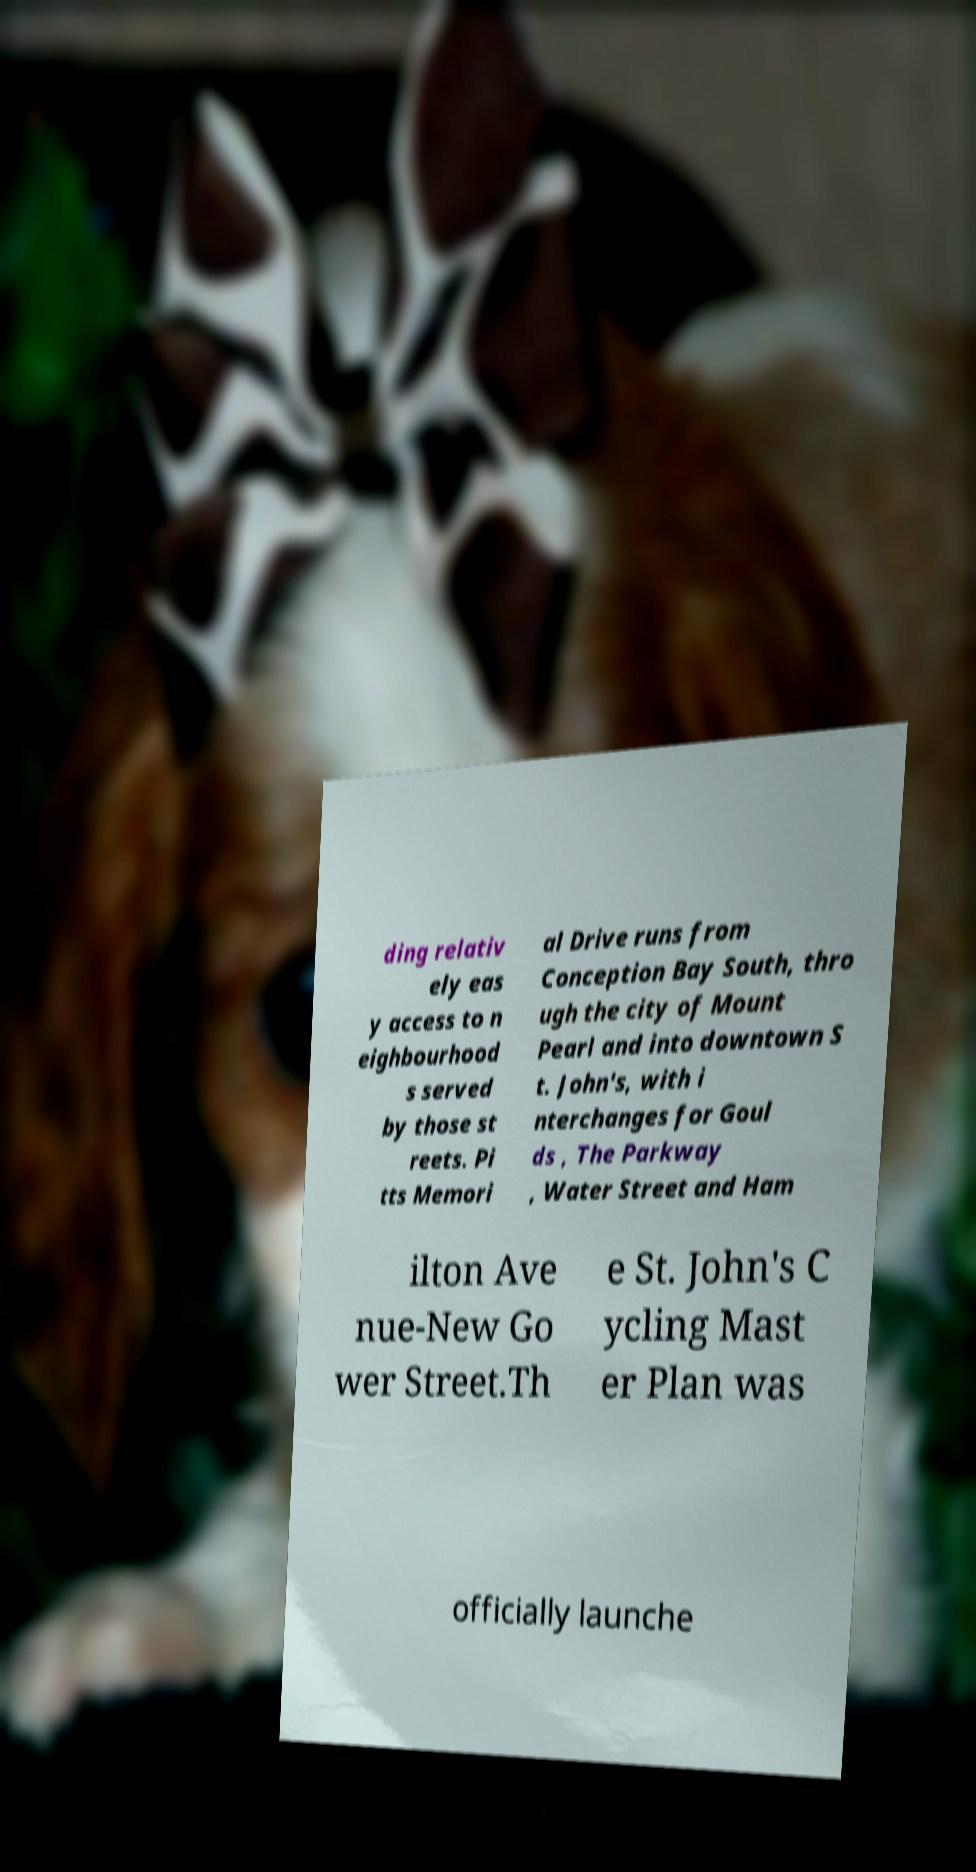What messages or text are displayed in this image? I need them in a readable, typed format. ding relativ ely eas y access to n eighbourhood s served by those st reets. Pi tts Memori al Drive runs from Conception Bay South, thro ugh the city of Mount Pearl and into downtown S t. John's, with i nterchanges for Goul ds , The Parkway , Water Street and Ham ilton Ave nue-New Go wer Street.Th e St. John's C ycling Mast er Plan was officially launche 